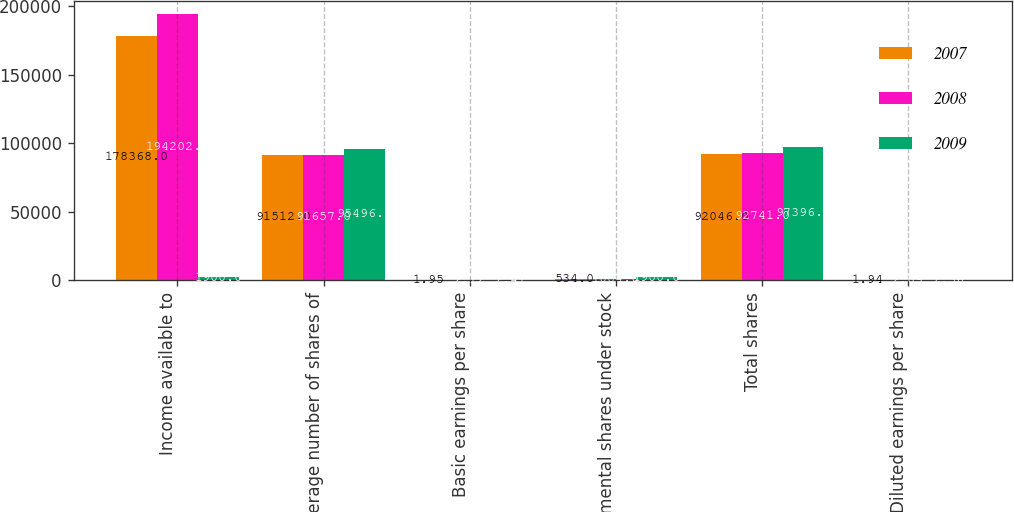<chart> <loc_0><loc_0><loc_500><loc_500><stacked_bar_chart><ecel><fcel>Income available to<fcel>Average number of shares of<fcel>Basic earnings per share<fcel>Incremental shares under stock<fcel>Total shares<fcel>Diluted earnings per share<nl><fcel>2007<fcel>178368<fcel>91512<fcel>1.95<fcel>534<fcel>92046<fcel>1.94<nl><fcel>2008<fcel>194202<fcel>91657<fcel>2.12<fcel>1084<fcel>92741<fcel>2.09<nl><fcel>2009<fcel>1900<fcel>95496<fcel>2.41<fcel>1900<fcel>97396<fcel>2.36<nl></chart> 